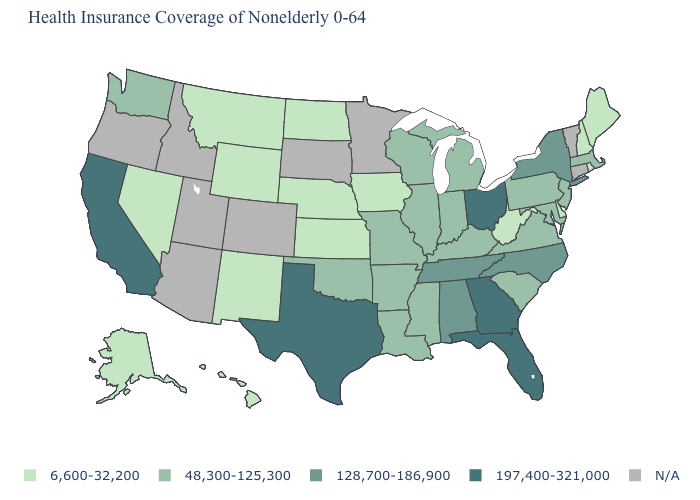What is the value of Texas?
Concise answer only. 197,400-321,000. What is the highest value in the MidWest ?
Give a very brief answer. 197,400-321,000. What is the value of Maine?
Concise answer only. 6,600-32,200. What is the value of Connecticut?
Write a very short answer. N/A. What is the value of West Virginia?
Write a very short answer. 6,600-32,200. What is the value of Louisiana?
Quick response, please. 48,300-125,300. Name the states that have a value in the range 6,600-32,200?
Answer briefly. Alaska, Delaware, Hawaii, Iowa, Kansas, Maine, Montana, Nebraska, Nevada, New Hampshire, New Mexico, North Dakota, Rhode Island, West Virginia, Wyoming. What is the value of Oklahoma?
Keep it brief. 48,300-125,300. Is the legend a continuous bar?
Quick response, please. No. Among the states that border New Mexico , does Oklahoma have the highest value?
Give a very brief answer. No. Name the states that have a value in the range 197,400-321,000?
Keep it brief. California, Florida, Georgia, Ohio, Texas. Does Rhode Island have the highest value in the USA?
Short answer required. No. What is the value of Idaho?
Concise answer only. N/A. 